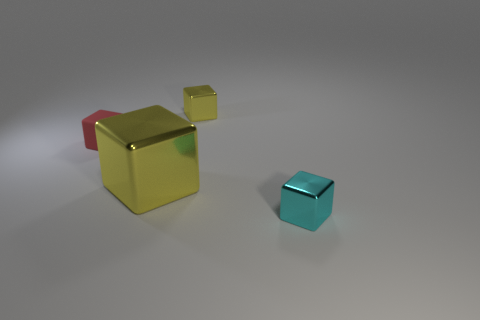The other yellow object that is made of the same material as the tiny yellow object is what size?
Provide a short and direct response. Large. Do the small rubber cube and the big metal cube have the same color?
Your answer should be compact. No. Does the small metallic object that is behind the red block have the same shape as the rubber thing?
Ensure brevity in your answer.  Yes. How many yellow things are the same size as the cyan shiny cube?
Offer a terse response. 1. There is a tiny metallic object that is the same color as the large thing; what is its shape?
Give a very brief answer. Cube. There is a yellow thing that is in front of the red object; are there any small yellow metallic cubes in front of it?
Make the answer very short. No. What number of objects are things that are on the right side of the tiny red matte thing or big yellow shiny blocks?
Offer a terse response. 3. How many yellow objects are there?
Give a very brief answer. 2. There is a large object that is made of the same material as the small cyan cube; what shape is it?
Make the answer very short. Cube. What size is the metallic cube on the left side of the cube that is behind the red thing?
Offer a terse response. Large. 